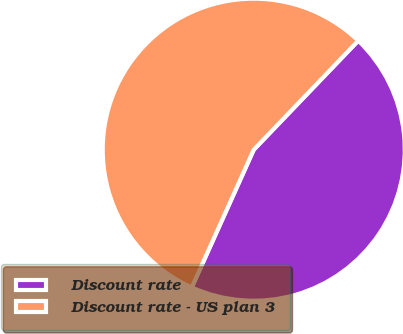Convert chart to OTSL. <chart><loc_0><loc_0><loc_500><loc_500><pie_chart><fcel>Discount rate<fcel>Discount rate - US plan 3<nl><fcel>44.57%<fcel>55.43%<nl></chart> 